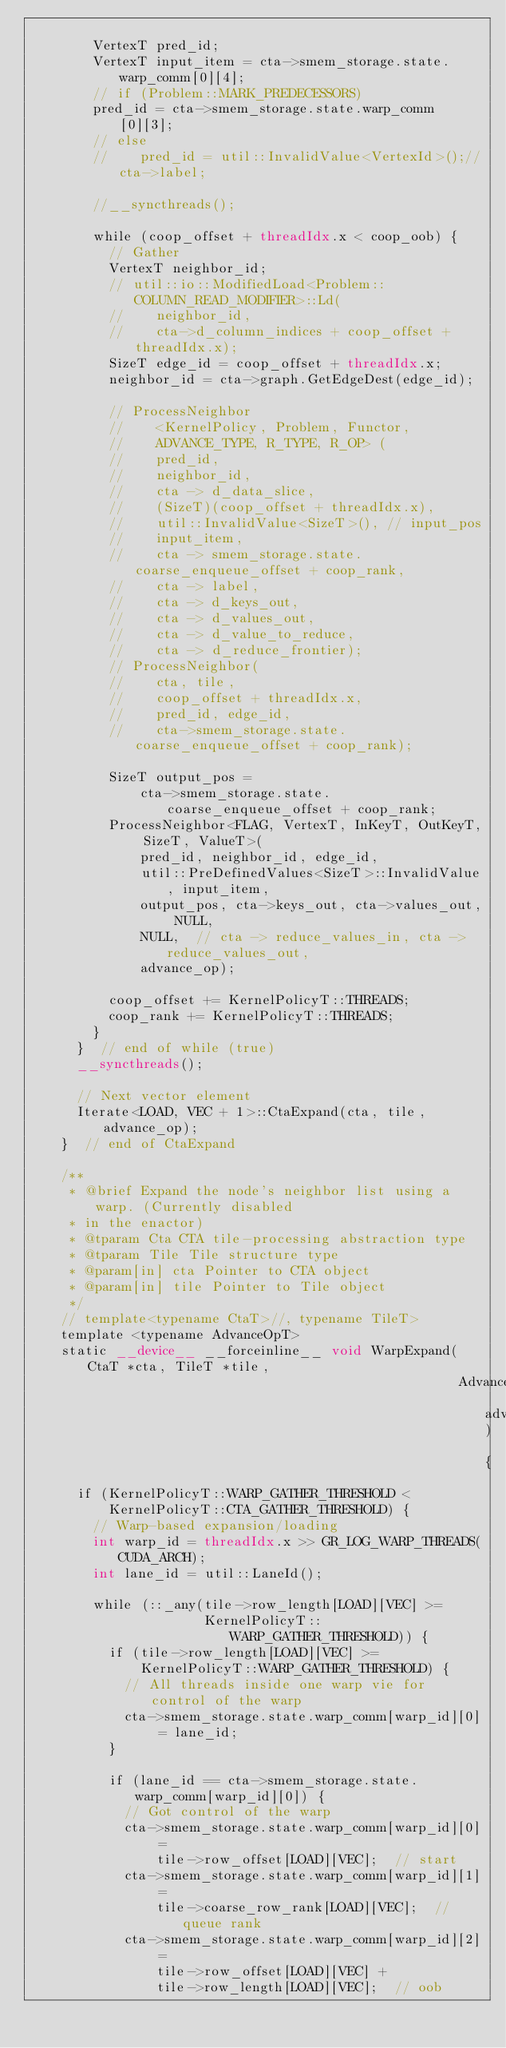Convert code to text. <code><loc_0><loc_0><loc_500><loc_500><_Cuda_>
        VertexT pred_id;
        VertexT input_item = cta->smem_storage.state.warp_comm[0][4];
        // if (Problem::MARK_PREDECESSORS)
        pred_id = cta->smem_storage.state.warp_comm[0][3];
        // else
        //    pred_id = util::InvalidValue<VertexId>();//cta->label;

        //__syncthreads();

        while (coop_offset + threadIdx.x < coop_oob) {
          // Gather
          VertexT neighbor_id;
          // util::io::ModifiedLoad<Problem::COLUMN_READ_MODIFIER>::Ld(
          //    neighbor_id,
          //    cta->d_column_indices + coop_offset + threadIdx.x);
          SizeT edge_id = coop_offset + threadIdx.x;
          neighbor_id = cta->graph.GetEdgeDest(edge_id);

          // ProcessNeighbor
          //    <KernelPolicy, Problem, Functor,
          //    ADVANCE_TYPE, R_TYPE, R_OP> (
          //    pred_id,
          //    neighbor_id,
          //    cta -> d_data_slice,
          //    (SizeT)(coop_offset + threadIdx.x),
          //    util::InvalidValue<SizeT>(), // input_pos
          //    input_item,
          //    cta -> smem_storage.state.coarse_enqueue_offset + coop_rank,
          //    cta -> label,
          //    cta -> d_keys_out,
          //    cta -> d_values_out,
          //    cta -> d_value_to_reduce,
          //    cta -> d_reduce_frontier);
          // ProcessNeighbor(
          //    cta, tile,
          //    coop_offset + threadIdx.x,
          //    pred_id, edge_id,
          //    cta->smem_storage.state.coarse_enqueue_offset + coop_rank);

          SizeT output_pos =
              cta->smem_storage.state.coarse_enqueue_offset + coop_rank;
          ProcessNeighbor<FLAG, VertexT, InKeyT, OutKeyT, SizeT, ValueT>(
              pred_id, neighbor_id, edge_id,
              util::PreDefinedValues<SizeT>::InvalidValue, input_item,
              output_pos, cta->keys_out, cta->values_out, NULL,
              NULL,  // cta -> reduce_values_in, cta -> reduce_values_out,
              advance_op);

          coop_offset += KernelPolicyT::THREADS;
          coop_rank += KernelPolicyT::THREADS;
        }
      }  // end of while (true)
      __syncthreads();

      // Next vector element
      Iterate<LOAD, VEC + 1>::CtaExpand(cta, tile, advance_op);
    }  // end of CtaExpand

    /**
     * @brief Expand the node's neighbor list using a warp. (Currently disabled
     * in the enactor)
     * @tparam Cta CTA tile-processing abstraction type
     * @tparam Tile Tile structure type
     * @param[in] cta Pointer to CTA object
     * @param[in] tile Pointer to Tile object
     */
    // template<typename CtaT>//, typename TileT>
    template <typename AdvanceOpT>
    static __device__ __forceinline__ void WarpExpand(CtaT *cta, TileT *tile,
                                                      AdvanceOpT advance_op) {
      if (KernelPolicyT::WARP_GATHER_THRESHOLD <
          KernelPolicyT::CTA_GATHER_THRESHOLD) {
        // Warp-based expansion/loading
        int warp_id = threadIdx.x >> GR_LOG_WARP_THREADS(CUDA_ARCH);
        int lane_id = util::LaneId();

        while (::_any(tile->row_length[LOAD][VEC] >=
                      KernelPolicyT::WARP_GATHER_THRESHOLD)) {
          if (tile->row_length[LOAD][VEC] >=
              KernelPolicyT::WARP_GATHER_THRESHOLD) {
            // All threads inside one warp vie for control of the warp
            cta->smem_storage.state.warp_comm[warp_id][0] = lane_id;
          }

          if (lane_id == cta->smem_storage.state.warp_comm[warp_id][0]) {
            // Got control of the warp
            cta->smem_storage.state.warp_comm[warp_id][0] =
                tile->row_offset[LOAD][VEC];  // start
            cta->smem_storage.state.warp_comm[warp_id][1] =
                tile->coarse_row_rank[LOAD][VEC];  // queue rank
            cta->smem_storage.state.warp_comm[warp_id][2] =
                tile->row_offset[LOAD][VEC] +
                tile->row_length[LOAD][VEC];  // oob</code> 